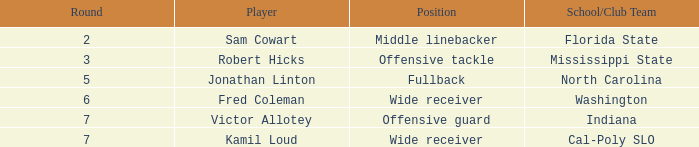In which school or club team can a choice of 198 be found? Indiana. 